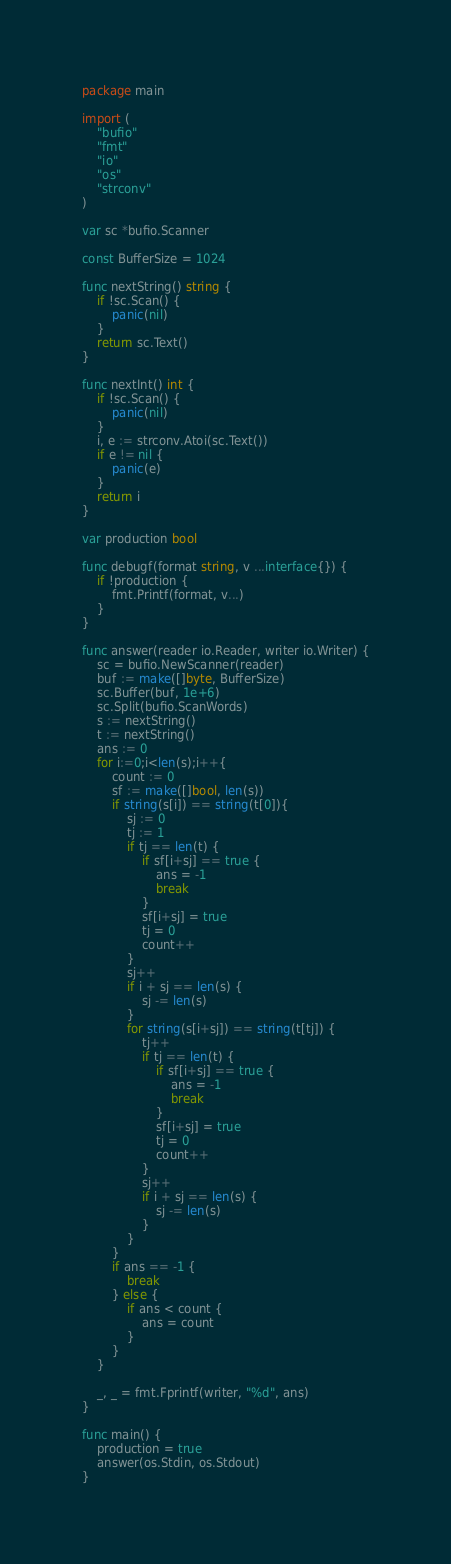<code> <loc_0><loc_0><loc_500><loc_500><_Go_>package main

import (
	"bufio"
	"fmt"
	"io"
	"os"
	"strconv"
)

var sc *bufio.Scanner

const BufferSize = 1024

func nextString() string {
	if !sc.Scan() {
		panic(nil)
	}
	return sc.Text()
}

func nextInt() int {
	if !sc.Scan() {
		panic(nil)
	}
	i, e := strconv.Atoi(sc.Text())
	if e != nil {
		panic(e)
	}
	return i
}

var production bool

func debugf(format string, v ...interface{}) {
	if !production {
		fmt.Printf(format, v...)
	}
}

func answer(reader io.Reader, writer io.Writer) {
	sc = bufio.NewScanner(reader)
	buf := make([]byte, BufferSize)
	sc.Buffer(buf, 1e+6)
	sc.Split(bufio.ScanWords)
	s := nextString()
	t := nextString()
	ans := 0
	for i:=0;i<len(s);i++{
		count := 0
		sf := make([]bool, len(s))
		if string(s[i]) == string(t[0]){
			sj := 0
			tj := 1
			if tj == len(t) {
				if sf[i+sj] == true {
					ans = -1
					break
				}
				sf[i+sj] = true
				tj = 0
				count++
			}
			sj++
			if i + sj == len(s) {
				sj -= len(s)
			}
			for string(s[i+sj]) == string(t[tj]) {
				tj++
				if tj == len(t) {
					if sf[i+sj] == true {
						ans = -1
						break
					}
					sf[i+sj] = true
					tj = 0
					count++
				}
				sj++
				if i + sj == len(s) {
					sj -= len(s)
				}
			}
		}
		if ans == -1 {
			break
		} else {
			if ans < count {
				ans = count
			}
		}
	}

	_, _ = fmt.Fprintf(writer, "%d", ans)
}

func main() {
	production = true
	answer(os.Stdin, os.Stdout)
}
</code> 